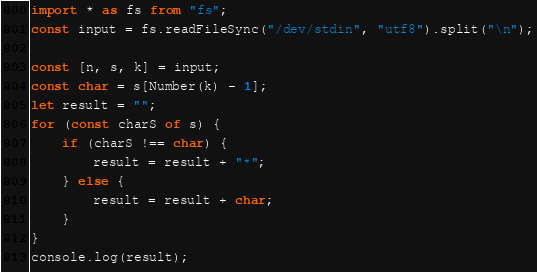<code> <loc_0><loc_0><loc_500><loc_500><_TypeScript_>import * as fs from "fs";
const input = fs.readFileSync("/dev/stdin", "utf8").split("\n");

const [n, s, k] = input;
const char = s[Number(k) - 1];
let result = "";
for (const charS of s) {
    if (charS !== char) {
        result = result + "*";
    } else {
        result = result + char;
    }
}
console.log(result);</code> 